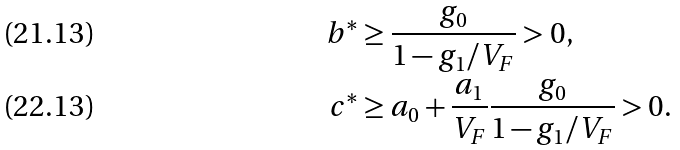<formula> <loc_0><loc_0><loc_500><loc_500>b ^ { * } & \geq \frac { g _ { 0 } } { 1 - g _ { 1 } / V _ { F } } > 0 , \\ c ^ { * } & \geq a _ { 0 } + \frac { a _ { 1 } } { V _ { F } } \frac { g _ { 0 } } { 1 - g _ { 1 } / V _ { F } } > 0 .</formula> 